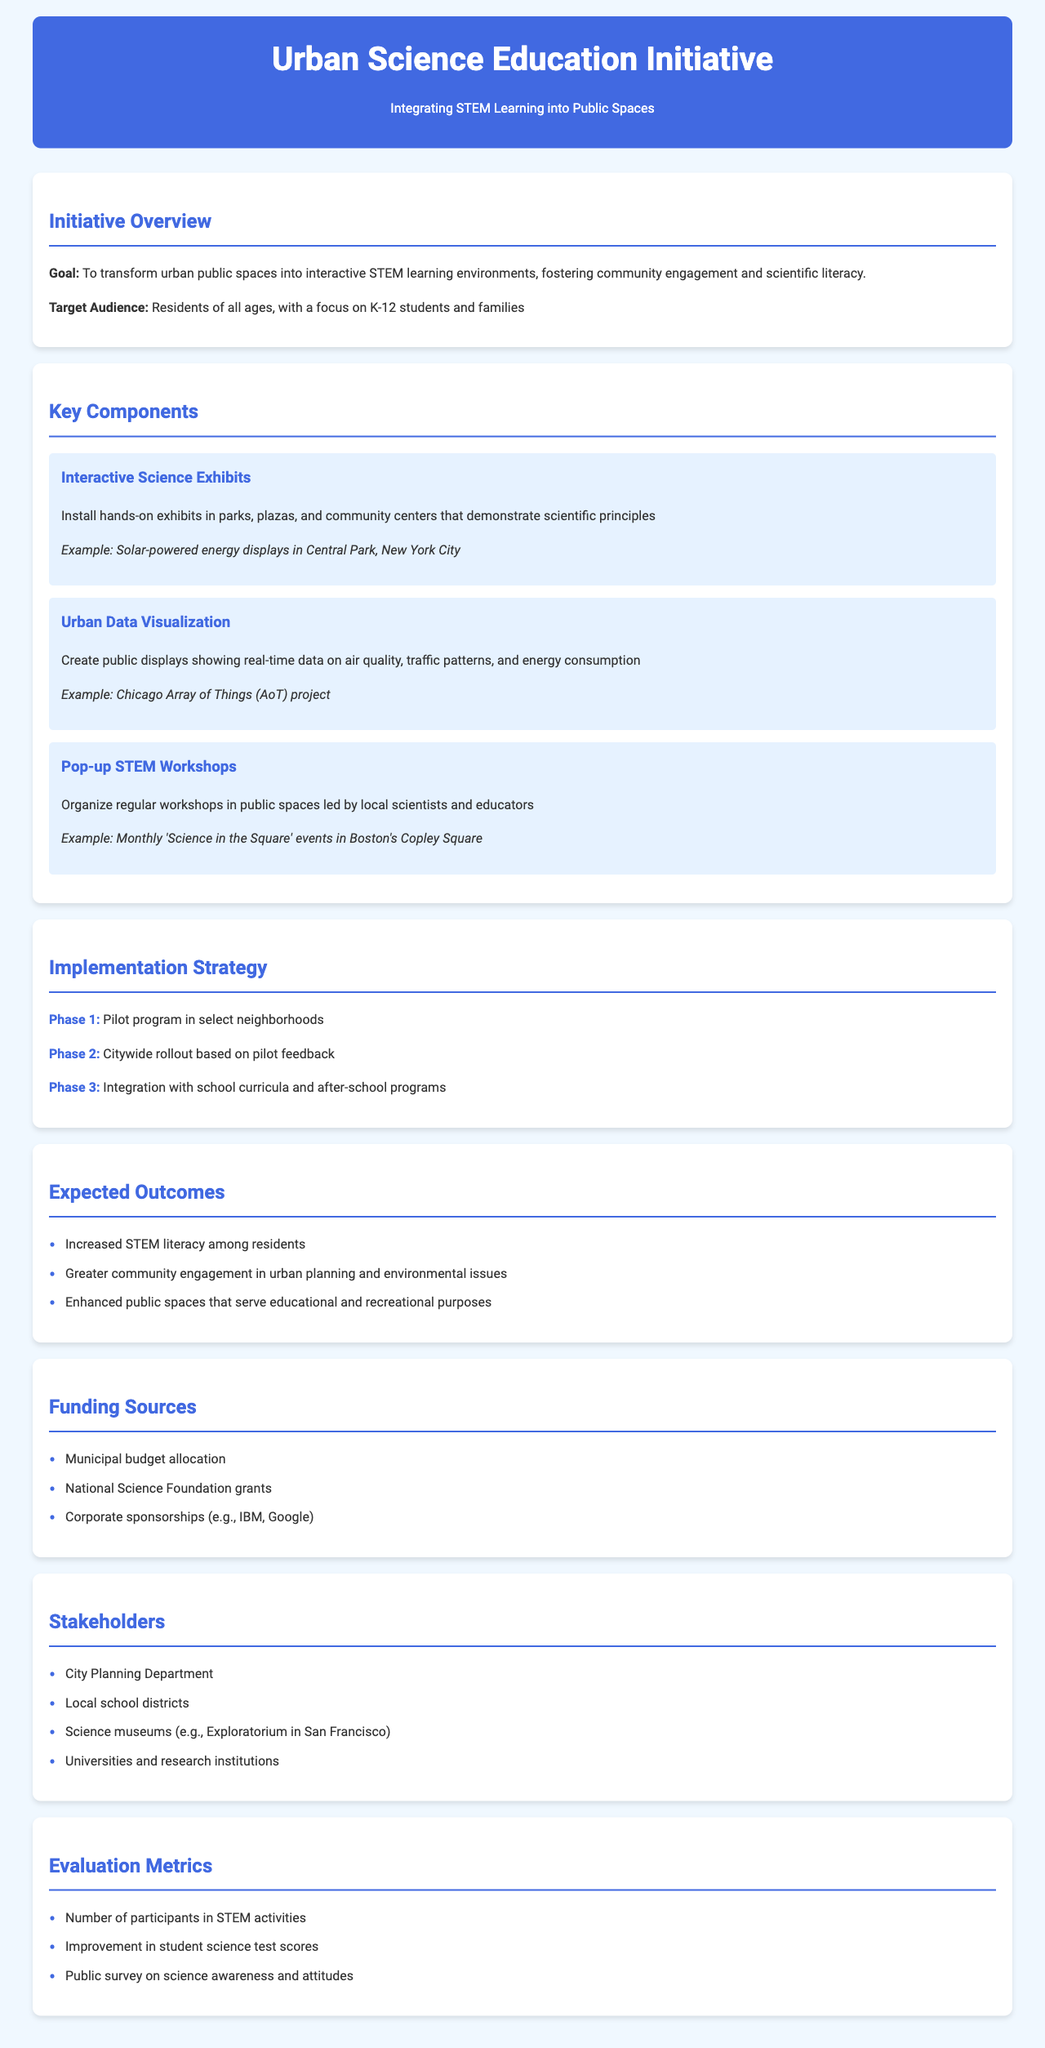what is the goal of the initiative? The goal is to transform urban public spaces into interactive STEM learning environments, fostering community engagement and scientific literacy.
Answer: To transform urban public spaces into interactive STEM learning environments, fostering community engagement and scientific literacy who is the target audience? The target audience is specified in the document, focusing on certain groups.
Answer: Residents of all ages, with a focus on K-12 students and families name one example of an interactive science exhibit mentioned. The document provides specific examples of components, including science exhibits.
Answer: Solar-powered energy displays in Central Park, New York City what is the first phase of the implementation strategy? The phases of implementation are outlined in the document, indicating the order of execution.
Answer: Pilot program in select neighborhoods how many expected outcomes are listed? The document enumerates the expected outcomes, allowing for a count based on the information provided.
Answer: Three which organization provides grant funding? The funding sources section lists organizations contributing to the initiative.
Answer: National Science Foundation what is one of the evaluation metrics? The metrics for evaluation are listed in the document, providing methods for measuring success.
Answer: Number of participants in STEM activities who is a stakeholder mentioned in the document? The stakeholders section identifies various entities involved in the initiative.
Answer: City Planning Department what type of workshops are being organized? The document specifies the type of workshops that will be held as part of the initiative.
Answer: Pop-up STEM Workshops what is the second phase of the implementation strategy? The phases of implementation are outlined sequentially, indicating the progression of the initiative.
Answer: Citywide rollout based on pilot feedback 